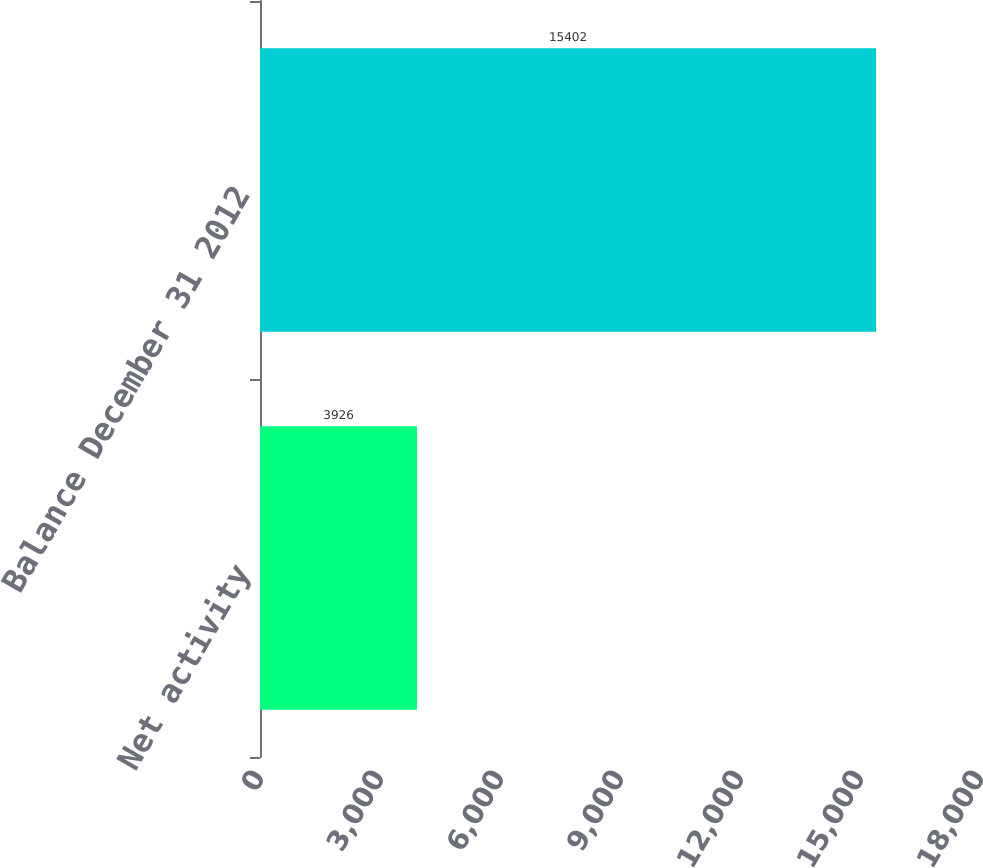<chart> <loc_0><loc_0><loc_500><loc_500><bar_chart><fcel>Net activity<fcel>Balance December 31 2012<nl><fcel>3926<fcel>15402<nl></chart> 